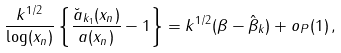<formula> <loc_0><loc_0><loc_500><loc_500>\frac { k ^ { 1 / 2 } } { \log ( x _ { n } ) } \left \{ \frac { \breve { a } _ { k _ { 1 } } ( x _ { n } ) } { a ( x _ { n } ) } - 1 \right \} = k ^ { 1 / 2 } ( \beta - \hat { \beta } _ { k } ) + o _ { P } ( 1 ) \, ,</formula> 